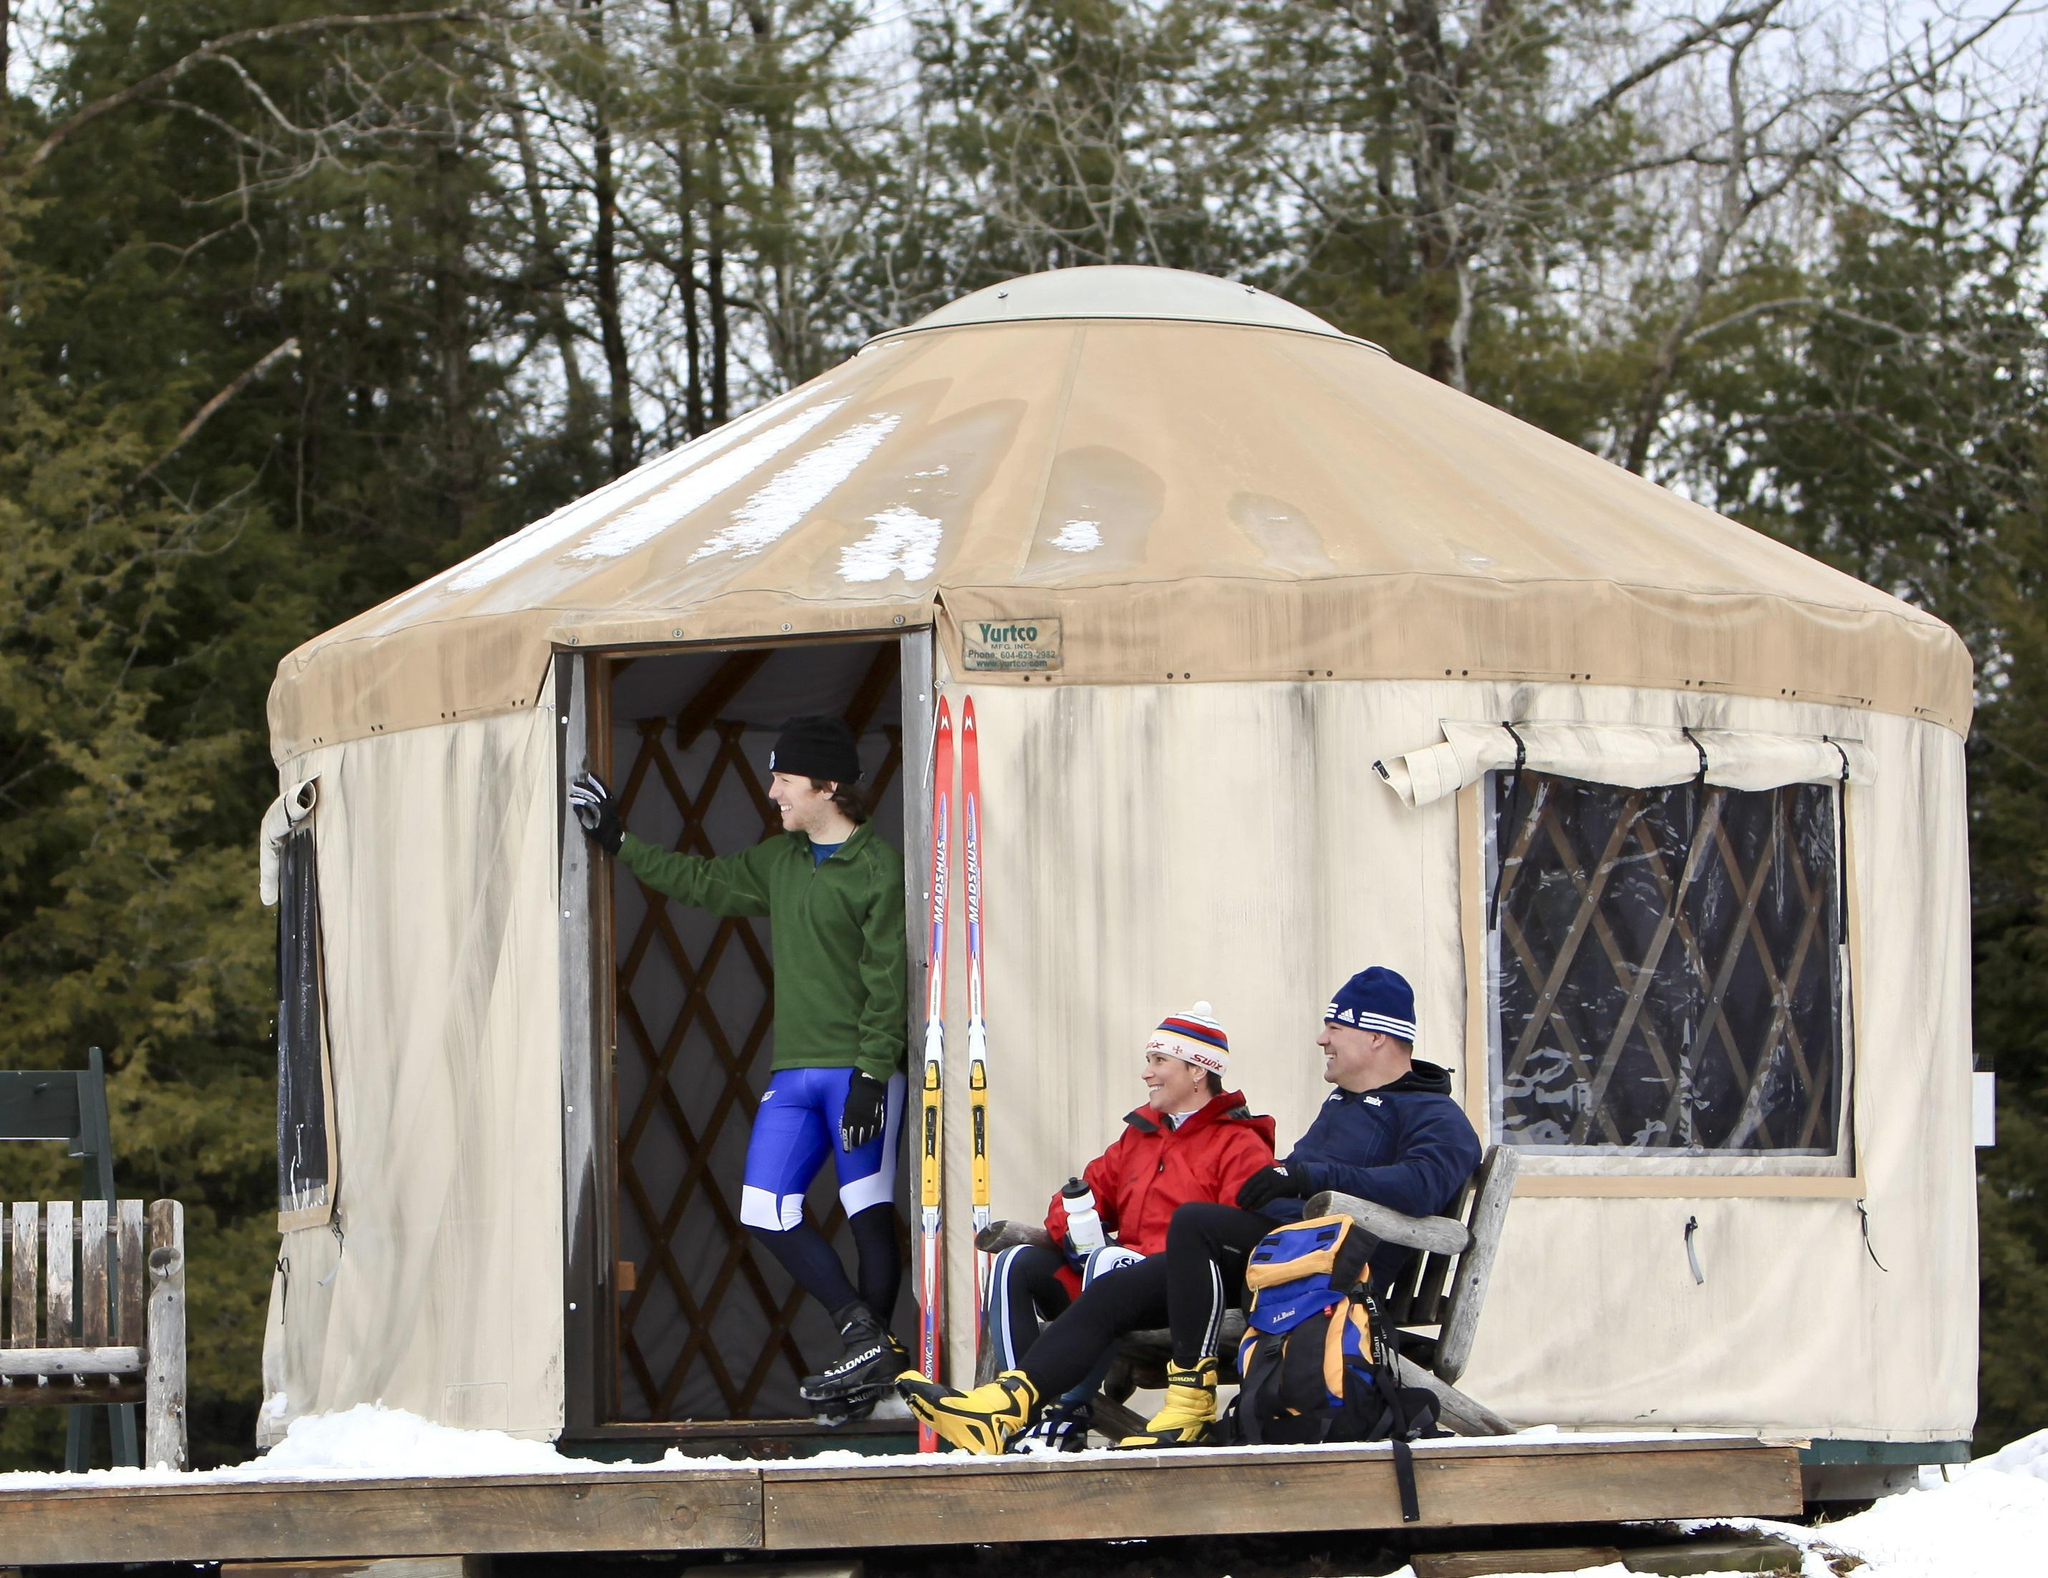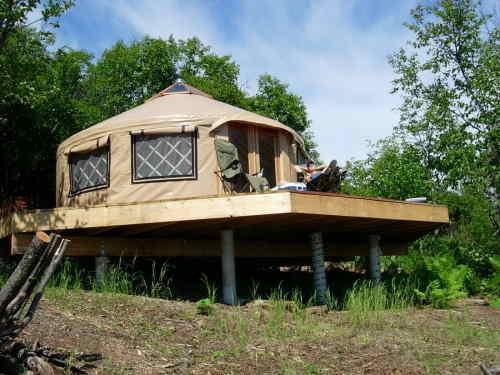The first image is the image on the left, the second image is the image on the right. Examine the images to the left and right. Is the description "Multiple people are visible outside one of the tents/yurts." accurate? Answer yes or no. Yes. The first image is the image on the left, the second image is the image on the right. Considering the images on both sides, is "All of the roofs are visible and tan" valid? Answer yes or no. Yes. 